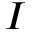Convert formula to latex. <formula><loc_0><loc_0><loc_500><loc_500>I</formula> 